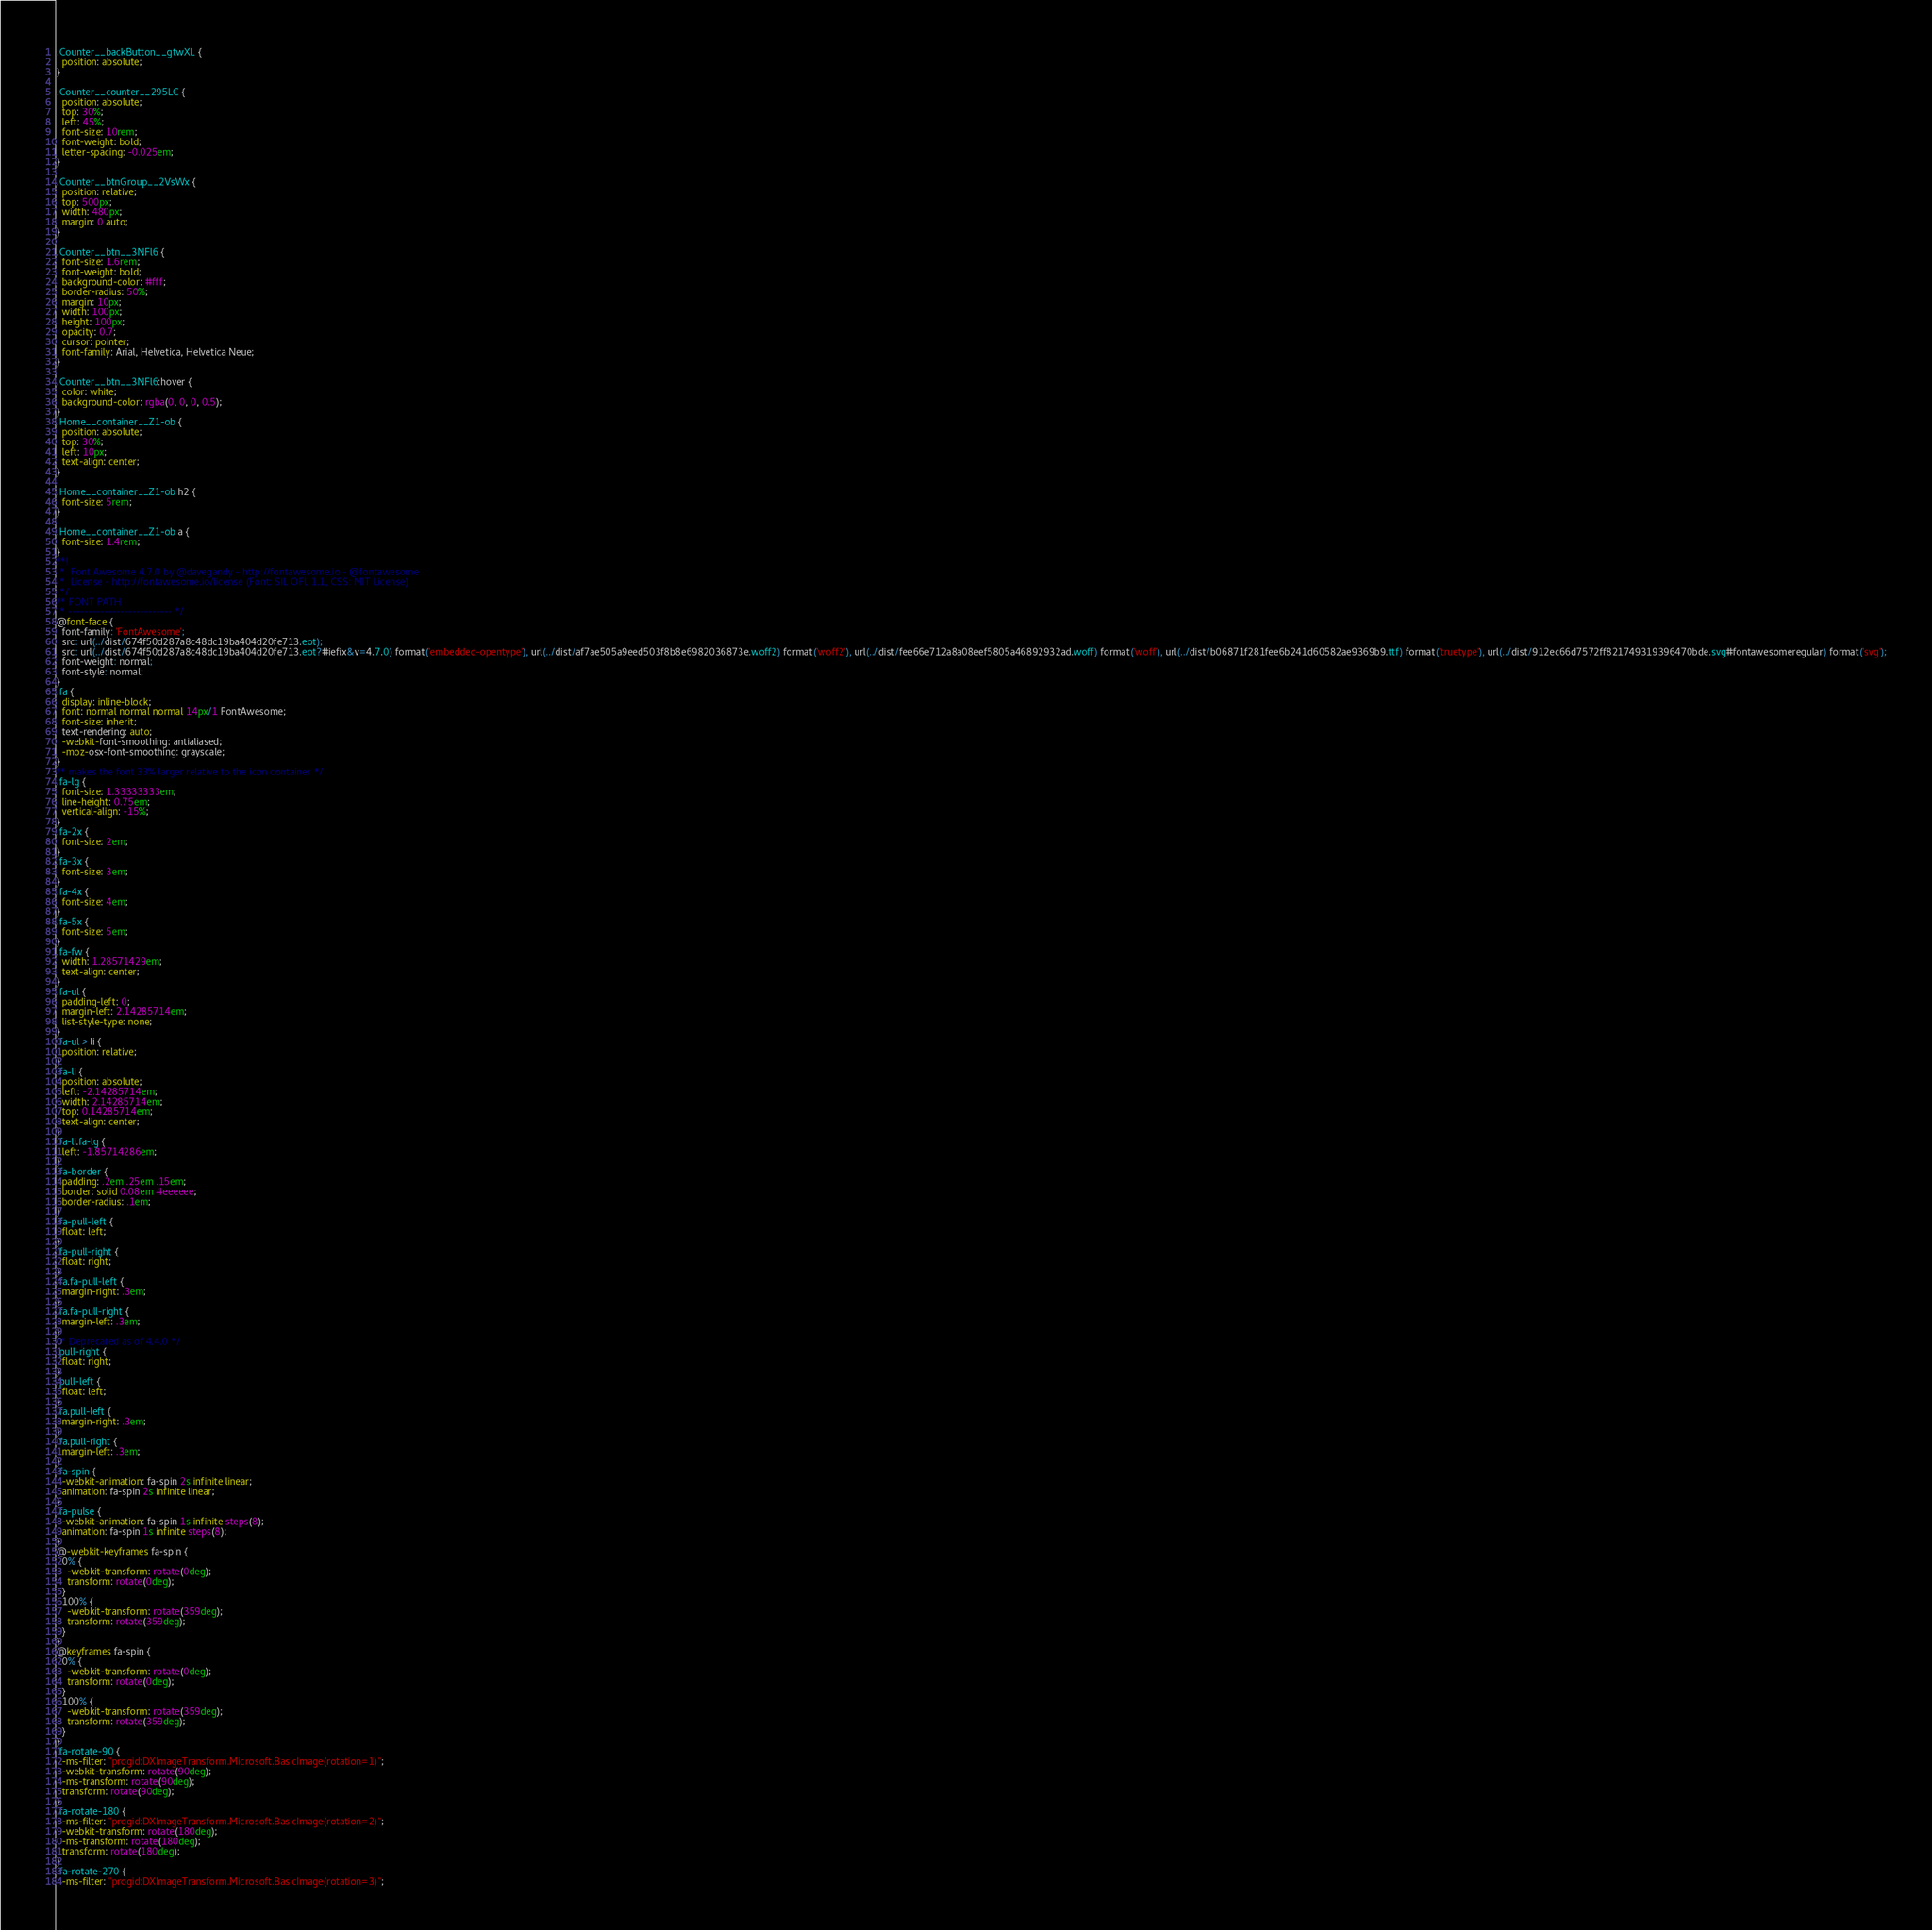<code> <loc_0><loc_0><loc_500><loc_500><_CSS_>.Counter__backButton__gtwXL {
  position: absolute;
}

.Counter__counter__295LC {
  position: absolute;
  top: 30%;
  left: 45%;
  font-size: 10rem;
  font-weight: bold;
  letter-spacing: -0.025em;
}

.Counter__btnGroup__2VsWx {
  position: relative;
  top: 500px;
  width: 480px;
  margin: 0 auto;
}

.Counter__btn__3NFl6 {
  font-size: 1.6rem;
  font-weight: bold;
  background-color: #fff;
  border-radius: 50%;
  margin: 10px;
  width: 100px;
  height: 100px;
  opacity: 0.7;
  cursor: pointer;
  font-family: Arial, Helvetica, Helvetica Neue;
}

.Counter__btn__3NFl6:hover {
  color: white;
  background-color: rgba(0, 0, 0, 0.5);
}
.Home__container__Z1-ob {
  position: absolute;
  top: 30%;
  left: 10px;
  text-align: center;
}

.Home__container__Z1-ob h2 {
  font-size: 5rem;
}

.Home__container__Z1-ob a {
  font-size: 1.4rem;
}
/*!
 *  Font Awesome 4.7.0 by @davegandy - http://fontawesome.io - @fontawesome
 *  License - http://fontawesome.io/license (Font: SIL OFL 1.1, CSS: MIT License)
 */
/* FONT PATH
 * -------------------------- */
@font-face {
  font-family: 'FontAwesome';
  src: url(../dist/674f50d287a8c48dc19ba404d20fe713.eot);
  src: url(../dist/674f50d287a8c48dc19ba404d20fe713.eot?#iefix&v=4.7.0) format('embedded-opentype'), url(../dist/af7ae505a9eed503f8b8e6982036873e.woff2) format('woff2'), url(../dist/fee66e712a8a08eef5805a46892932ad.woff) format('woff'), url(../dist/b06871f281fee6b241d60582ae9369b9.ttf) format('truetype'), url(../dist/912ec66d7572ff821749319396470bde.svg#fontawesomeregular) format('svg');
  font-weight: normal;
  font-style: normal;
}
.fa {
  display: inline-block;
  font: normal normal normal 14px/1 FontAwesome;
  font-size: inherit;
  text-rendering: auto;
  -webkit-font-smoothing: antialiased;
  -moz-osx-font-smoothing: grayscale;
}
/* makes the font 33% larger relative to the icon container */
.fa-lg {
  font-size: 1.33333333em;
  line-height: 0.75em;
  vertical-align: -15%;
}
.fa-2x {
  font-size: 2em;
}
.fa-3x {
  font-size: 3em;
}
.fa-4x {
  font-size: 4em;
}
.fa-5x {
  font-size: 5em;
}
.fa-fw {
  width: 1.28571429em;
  text-align: center;
}
.fa-ul {
  padding-left: 0;
  margin-left: 2.14285714em;
  list-style-type: none;
}
.fa-ul > li {
  position: relative;
}
.fa-li {
  position: absolute;
  left: -2.14285714em;
  width: 2.14285714em;
  top: 0.14285714em;
  text-align: center;
}
.fa-li.fa-lg {
  left: -1.85714286em;
}
.fa-border {
  padding: .2em .25em .15em;
  border: solid 0.08em #eeeeee;
  border-radius: .1em;
}
.fa-pull-left {
  float: left;
}
.fa-pull-right {
  float: right;
}
.fa.fa-pull-left {
  margin-right: .3em;
}
.fa.fa-pull-right {
  margin-left: .3em;
}
/* Deprecated as of 4.4.0 */
.pull-right {
  float: right;
}
.pull-left {
  float: left;
}
.fa.pull-left {
  margin-right: .3em;
}
.fa.pull-right {
  margin-left: .3em;
}
.fa-spin {
  -webkit-animation: fa-spin 2s infinite linear;
  animation: fa-spin 2s infinite linear;
}
.fa-pulse {
  -webkit-animation: fa-spin 1s infinite steps(8);
  animation: fa-spin 1s infinite steps(8);
}
@-webkit-keyframes fa-spin {
  0% {
    -webkit-transform: rotate(0deg);
    transform: rotate(0deg);
  }
  100% {
    -webkit-transform: rotate(359deg);
    transform: rotate(359deg);
  }
}
@keyframes fa-spin {
  0% {
    -webkit-transform: rotate(0deg);
    transform: rotate(0deg);
  }
  100% {
    -webkit-transform: rotate(359deg);
    transform: rotate(359deg);
  }
}
.fa-rotate-90 {
  -ms-filter: "progid:DXImageTransform.Microsoft.BasicImage(rotation=1)";
  -webkit-transform: rotate(90deg);
  -ms-transform: rotate(90deg);
  transform: rotate(90deg);
}
.fa-rotate-180 {
  -ms-filter: "progid:DXImageTransform.Microsoft.BasicImage(rotation=2)";
  -webkit-transform: rotate(180deg);
  -ms-transform: rotate(180deg);
  transform: rotate(180deg);
}
.fa-rotate-270 {
  -ms-filter: "progid:DXImageTransform.Microsoft.BasicImage(rotation=3)";</code> 